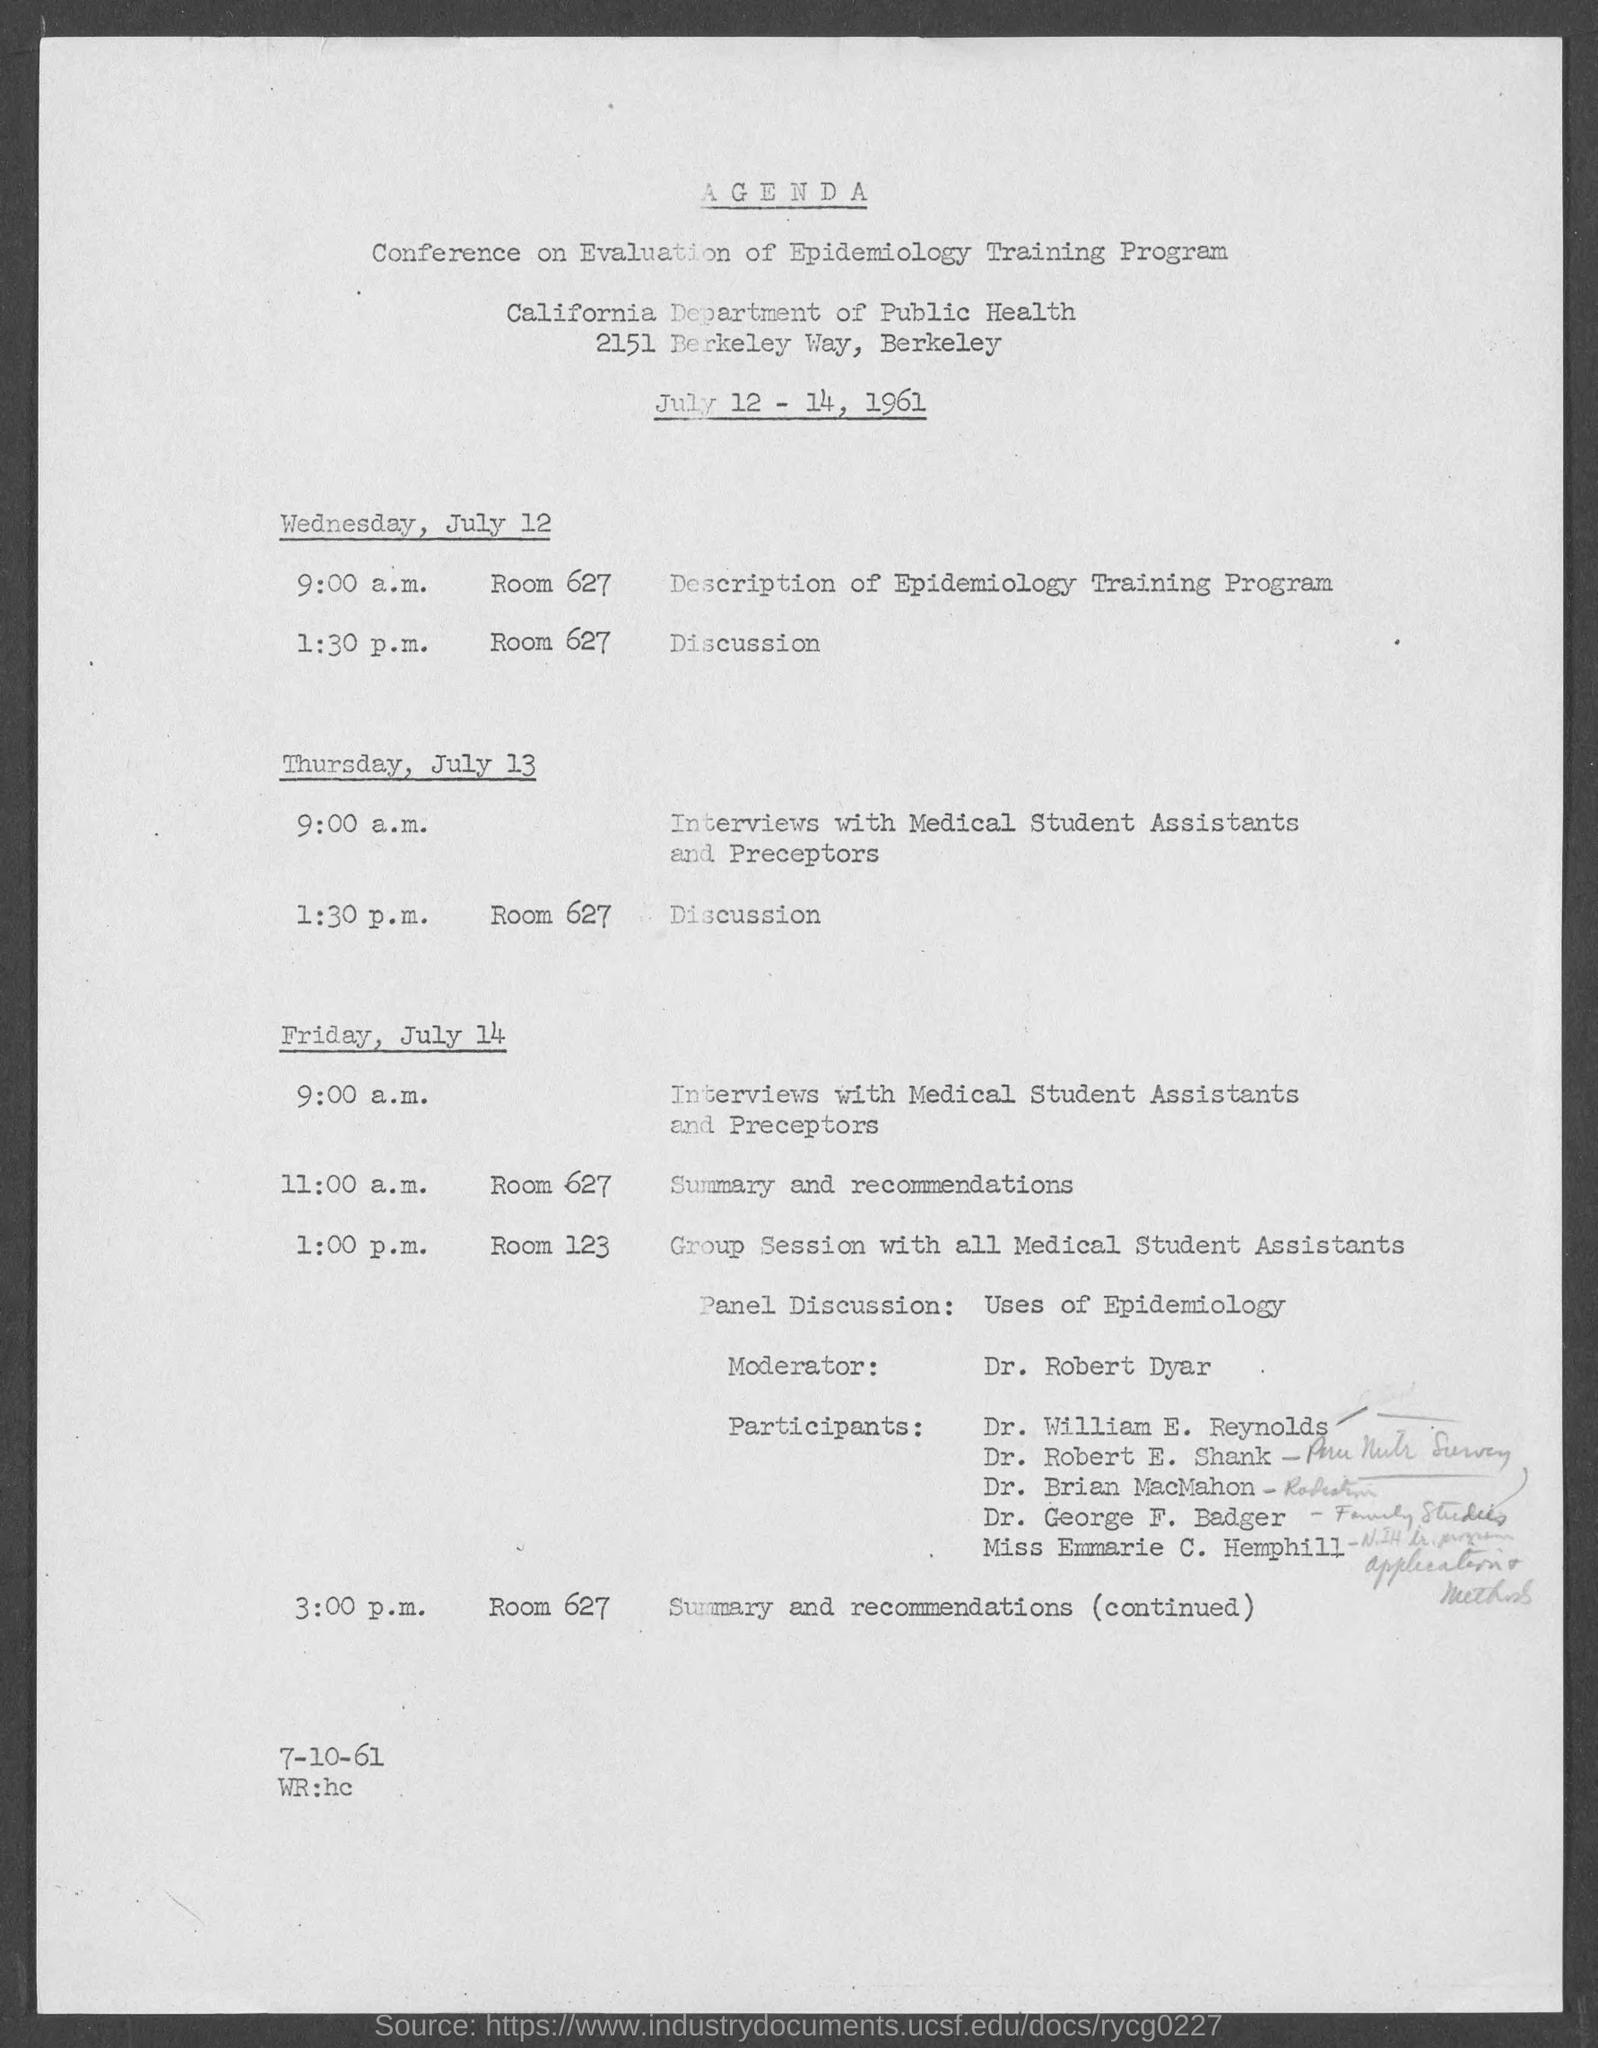When was the Conference on Evaluation of Epidemiology Training Program held?
Make the answer very short. JULY 12 - 14, 1961. What time is the description of Epidemiology Training program held on Wednesday, July 12?
Make the answer very short. 9:00 A.M. Which date is the Group session with all Medical Sstudent Assistants held?
Your answer should be very brief. Friday, July 14. What time is the interviews with medical student assistants and preceptors scheduled on Friday, July 14?
Your answer should be very brief. 9:00 a.m. Where are the discussions held on Wednesday, July 12?
Offer a very short reply. ROOM 627. Who is the Moderator in the Group session with all medical assistants?
Offer a very short reply. Dr. Robert Dyar. 